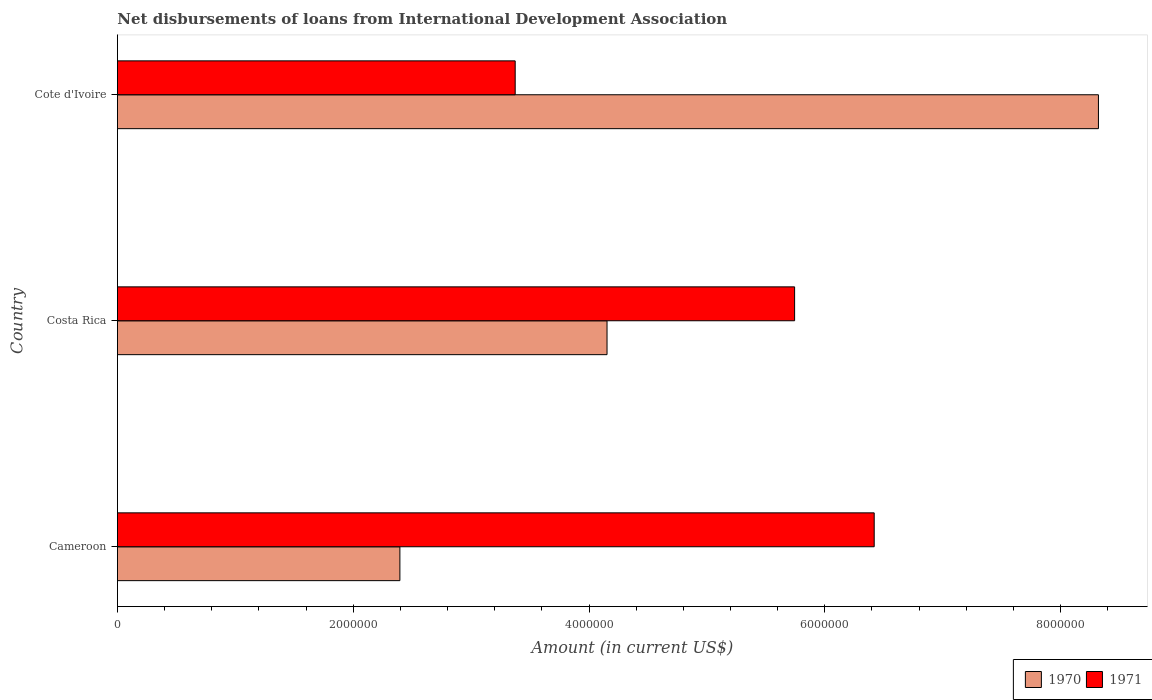Are the number of bars on each tick of the Y-axis equal?
Ensure brevity in your answer.  Yes. How many bars are there on the 1st tick from the top?
Ensure brevity in your answer.  2. How many bars are there on the 1st tick from the bottom?
Offer a very short reply. 2. In how many cases, is the number of bars for a given country not equal to the number of legend labels?
Offer a terse response. 0. What is the amount of loans disbursed in 1971 in Costa Rica?
Your answer should be very brief. 5.74e+06. Across all countries, what is the maximum amount of loans disbursed in 1971?
Keep it short and to the point. 6.42e+06. Across all countries, what is the minimum amount of loans disbursed in 1970?
Your response must be concise. 2.40e+06. In which country was the amount of loans disbursed in 1970 maximum?
Your answer should be compact. Cote d'Ivoire. In which country was the amount of loans disbursed in 1970 minimum?
Offer a terse response. Cameroon. What is the total amount of loans disbursed in 1971 in the graph?
Keep it short and to the point. 1.55e+07. What is the difference between the amount of loans disbursed in 1970 in Costa Rica and that in Cote d'Ivoire?
Your answer should be very brief. -4.17e+06. What is the difference between the amount of loans disbursed in 1971 in Costa Rica and the amount of loans disbursed in 1970 in Cote d'Ivoire?
Offer a very short reply. -2.58e+06. What is the average amount of loans disbursed in 1970 per country?
Provide a short and direct response. 4.96e+06. What is the difference between the amount of loans disbursed in 1971 and amount of loans disbursed in 1970 in Costa Rica?
Provide a short and direct response. 1.59e+06. What is the ratio of the amount of loans disbursed in 1970 in Costa Rica to that in Cote d'Ivoire?
Keep it short and to the point. 0.5. Is the amount of loans disbursed in 1971 in Cameroon less than that in Cote d'Ivoire?
Offer a terse response. No. Is the difference between the amount of loans disbursed in 1971 in Costa Rica and Cote d'Ivoire greater than the difference between the amount of loans disbursed in 1970 in Costa Rica and Cote d'Ivoire?
Provide a succinct answer. Yes. What is the difference between the highest and the second highest amount of loans disbursed in 1970?
Offer a terse response. 4.17e+06. What is the difference between the highest and the lowest amount of loans disbursed in 1970?
Keep it short and to the point. 5.92e+06. In how many countries, is the amount of loans disbursed in 1971 greater than the average amount of loans disbursed in 1971 taken over all countries?
Make the answer very short. 2. How many bars are there?
Give a very brief answer. 6. How many countries are there in the graph?
Ensure brevity in your answer.  3. What is the difference between two consecutive major ticks on the X-axis?
Provide a succinct answer. 2.00e+06. Are the values on the major ticks of X-axis written in scientific E-notation?
Provide a succinct answer. No. Does the graph contain any zero values?
Make the answer very short. No. How are the legend labels stacked?
Ensure brevity in your answer.  Horizontal. What is the title of the graph?
Make the answer very short. Net disbursements of loans from International Development Association. Does "1987" appear as one of the legend labels in the graph?
Your answer should be compact. No. What is the label or title of the X-axis?
Offer a terse response. Amount (in current US$). What is the label or title of the Y-axis?
Your response must be concise. Country. What is the Amount (in current US$) of 1970 in Cameroon?
Your answer should be very brief. 2.40e+06. What is the Amount (in current US$) of 1971 in Cameroon?
Offer a very short reply. 6.42e+06. What is the Amount (in current US$) of 1970 in Costa Rica?
Your answer should be compact. 4.15e+06. What is the Amount (in current US$) in 1971 in Costa Rica?
Make the answer very short. 5.74e+06. What is the Amount (in current US$) of 1970 in Cote d'Ivoire?
Give a very brief answer. 8.32e+06. What is the Amount (in current US$) of 1971 in Cote d'Ivoire?
Make the answer very short. 3.37e+06. Across all countries, what is the maximum Amount (in current US$) in 1970?
Provide a short and direct response. 8.32e+06. Across all countries, what is the maximum Amount (in current US$) of 1971?
Give a very brief answer. 6.42e+06. Across all countries, what is the minimum Amount (in current US$) of 1970?
Give a very brief answer. 2.40e+06. Across all countries, what is the minimum Amount (in current US$) in 1971?
Offer a very short reply. 3.37e+06. What is the total Amount (in current US$) in 1970 in the graph?
Your response must be concise. 1.49e+07. What is the total Amount (in current US$) in 1971 in the graph?
Give a very brief answer. 1.55e+07. What is the difference between the Amount (in current US$) in 1970 in Cameroon and that in Costa Rica?
Your answer should be compact. -1.76e+06. What is the difference between the Amount (in current US$) of 1971 in Cameroon and that in Costa Rica?
Provide a short and direct response. 6.75e+05. What is the difference between the Amount (in current US$) of 1970 in Cameroon and that in Cote d'Ivoire?
Ensure brevity in your answer.  -5.92e+06. What is the difference between the Amount (in current US$) of 1971 in Cameroon and that in Cote d'Ivoire?
Your answer should be very brief. 3.04e+06. What is the difference between the Amount (in current US$) of 1970 in Costa Rica and that in Cote d'Ivoire?
Offer a very short reply. -4.17e+06. What is the difference between the Amount (in current US$) in 1971 in Costa Rica and that in Cote d'Ivoire?
Offer a very short reply. 2.37e+06. What is the difference between the Amount (in current US$) in 1970 in Cameroon and the Amount (in current US$) in 1971 in Costa Rica?
Offer a terse response. -3.35e+06. What is the difference between the Amount (in current US$) of 1970 in Cameroon and the Amount (in current US$) of 1971 in Cote d'Ivoire?
Provide a short and direct response. -9.78e+05. What is the difference between the Amount (in current US$) of 1970 in Costa Rica and the Amount (in current US$) of 1971 in Cote d'Ivoire?
Ensure brevity in your answer.  7.79e+05. What is the average Amount (in current US$) of 1970 per country?
Provide a succinct answer. 4.96e+06. What is the average Amount (in current US$) of 1971 per country?
Give a very brief answer. 5.18e+06. What is the difference between the Amount (in current US$) of 1970 and Amount (in current US$) of 1971 in Cameroon?
Keep it short and to the point. -4.02e+06. What is the difference between the Amount (in current US$) of 1970 and Amount (in current US$) of 1971 in Costa Rica?
Your answer should be compact. -1.59e+06. What is the difference between the Amount (in current US$) of 1970 and Amount (in current US$) of 1971 in Cote d'Ivoire?
Offer a terse response. 4.95e+06. What is the ratio of the Amount (in current US$) in 1970 in Cameroon to that in Costa Rica?
Provide a succinct answer. 0.58. What is the ratio of the Amount (in current US$) in 1971 in Cameroon to that in Costa Rica?
Keep it short and to the point. 1.12. What is the ratio of the Amount (in current US$) of 1970 in Cameroon to that in Cote d'Ivoire?
Make the answer very short. 0.29. What is the ratio of the Amount (in current US$) in 1971 in Cameroon to that in Cote d'Ivoire?
Offer a very short reply. 1.9. What is the ratio of the Amount (in current US$) of 1970 in Costa Rica to that in Cote d'Ivoire?
Offer a terse response. 0.5. What is the ratio of the Amount (in current US$) in 1971 in Costa Rica to that in Cote d'Ivoire?
Make the answer very short. 1.7. What is the difference between the highest and the second highest Amount (in current US$) in 1970?
Make the answer very short. 4.17e+06. What is the difference between the highest and the second highest Amount (in current US$) in 1971?
Offer a terse response. 6.75e+05. What is the difference between the highest and the lowest Amount (in current US$) of 1970?
Provide a short and direct response. 5.92e+06. What is the difference between the highest and the lowest Amount (in current US$) of 1971?
Offer a very short reply. 3.04e+06. 